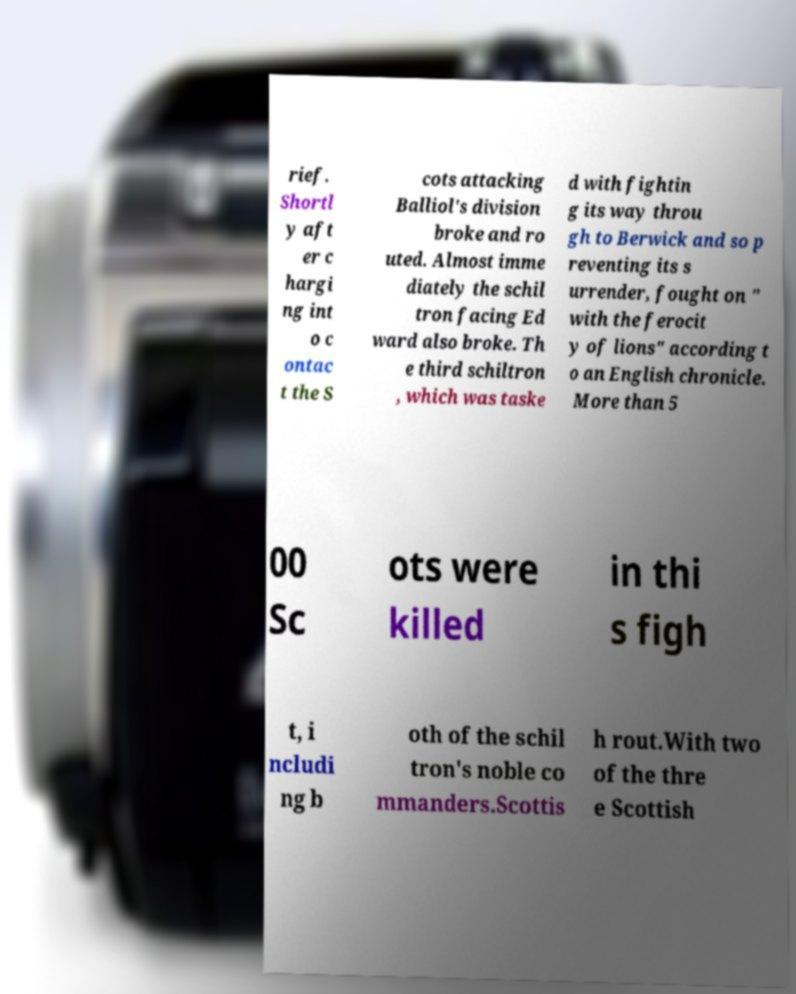Can you accurately transcribe the text from the provided image for me? rief. Shortl y aft er c hargi ng int o c ontac t the S cots attacking Balliol's division broke and ro uted. Almost imme diately the schil tron facing Ed ward also broke. Th e third schiltron , which was taske d with fightin g its way throu gh to Berwick and so p reventing its s urrender, fought on " with the ferocit y of lions" according t o an English chronicle. More than 5 00 Sc ots were killed in thi s figh t, i ncludi ng b oth of the schil tron's noble co mmanders.Scottis h rout.With two of the thre e Scottish 